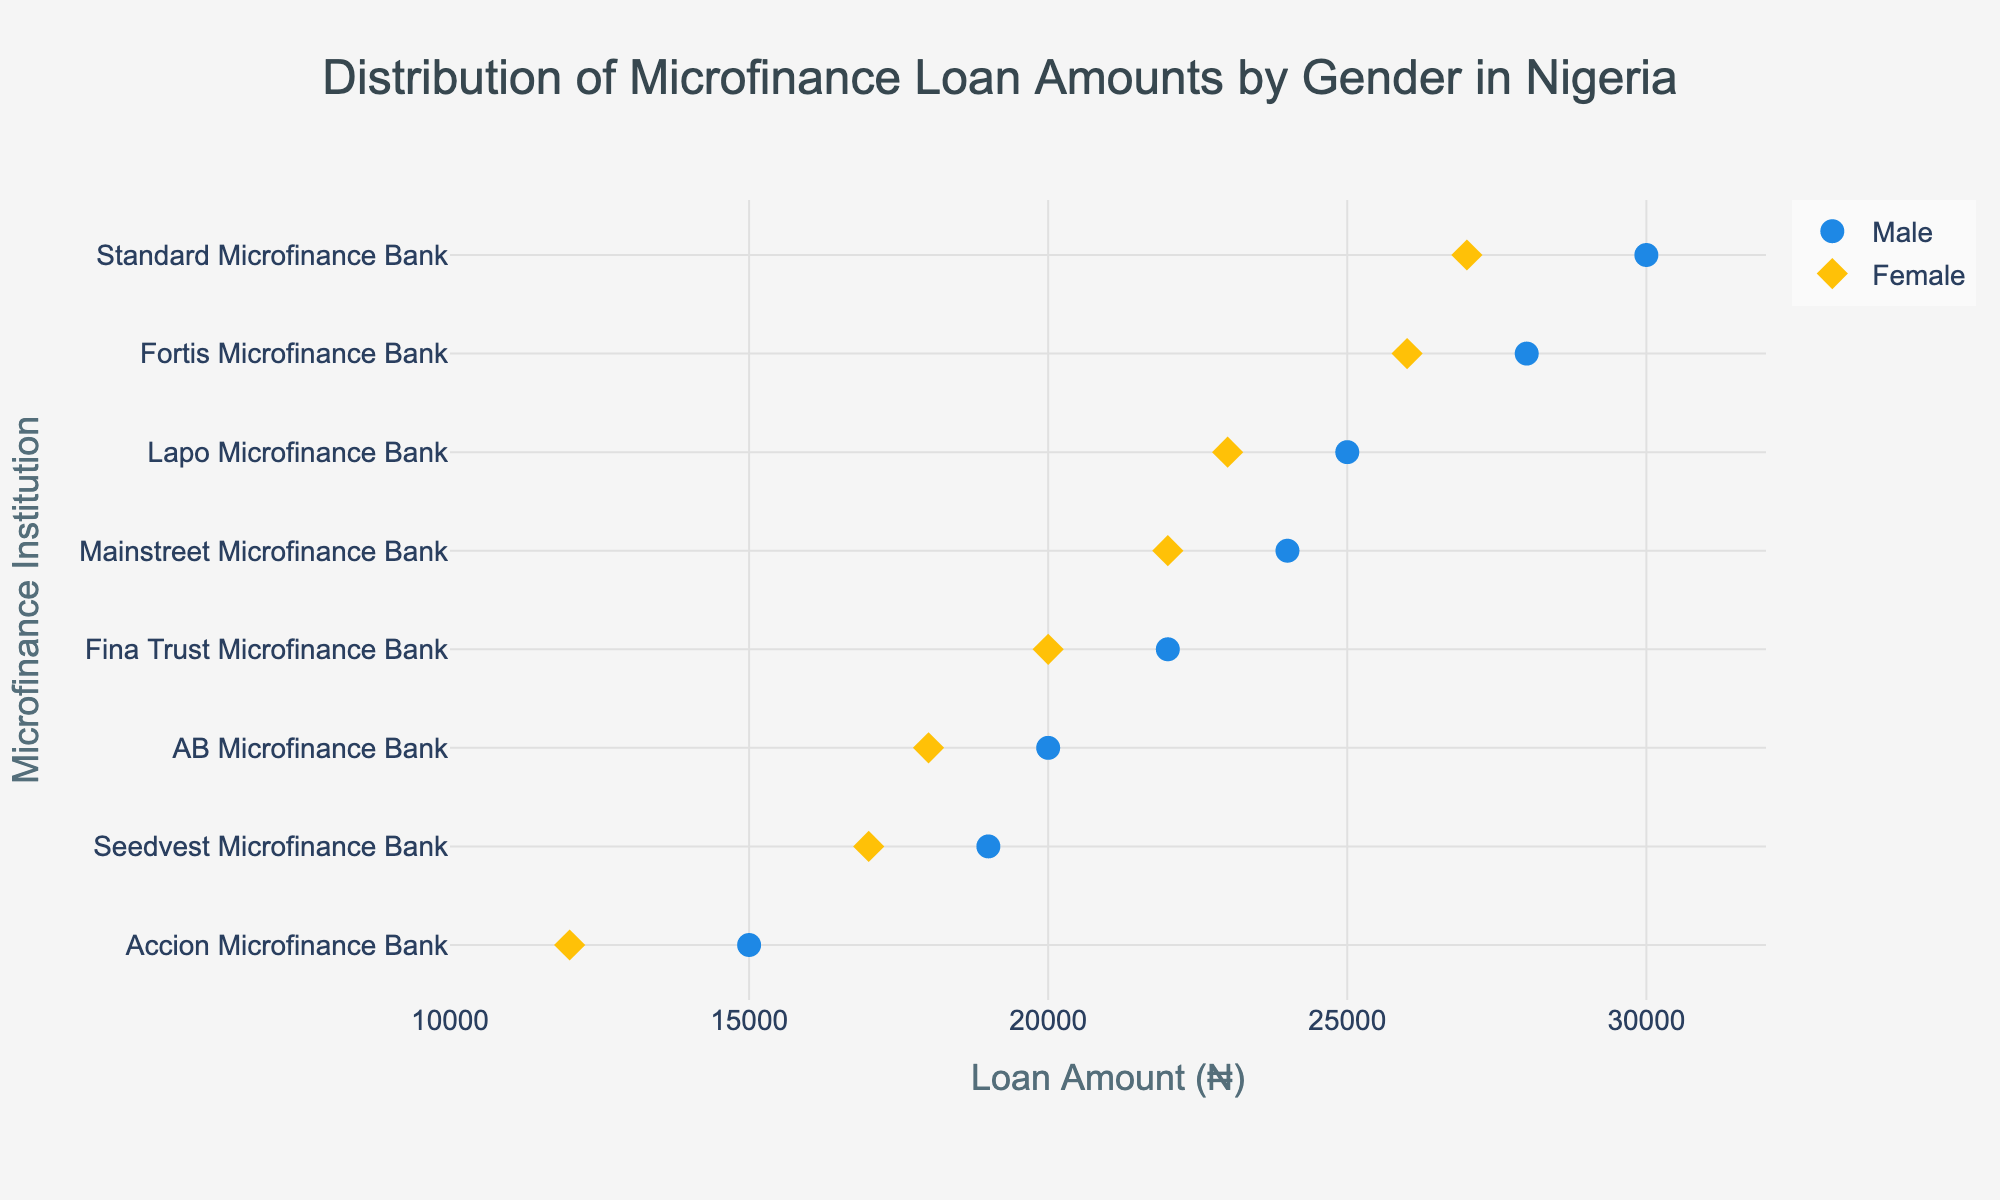what is the range of loan amounts for Standard Microfinance Bank? The male loan amount for Standard Microfinance Bank is ₦30,000 and the female loan amount is ₦27,000. The range is calculated as the difference between these values: 30,000 - 27,000.
Answer: ₦3,000 what is the average loan amount for AB Microfinance Bank? The loan amounts for AB Microfinance Bank are ₦20,000 for males and ₦18,000 for females. To find the average, sum these amounts and divide by 2: (20,000 + 18,000) / 2.
Answer: ₦19,000 How does the loan amount for males compare to females at Fina Trust Microfinance Bank? For Fina Trust Microfinance Bank, the loan amount for males is ₦22,000, while for females it is ₦20,000. Compare these two values: 22,000 is greater than 20,000.
Answer: Males receive ₦2,000 more Which microfinance institution offers the highest loan amount for females? To find this, compare the loan amounts for females across all institutions. Standard Microfinance Bank offers the highest at ₦27,000.
Answer: Standard Microfinance Bank What is the median loan amount for males across all microfinance institutions? The male loan amounts are: ₦15,000, ₦19,000, ₦20,000, ₦22,000, ₦24,000, ₦25,000, ₦28,000, and ₦30,000. Arrange these values in ascending order and find the middle value(s). For eight values, the median is the average of the 4th and 5th values: (22,000 + 24,000) / 2.
Answer: ₦23,000 What is the difference in loan amounts between males and females at Lapo Microfinance Bank? For Lapo Microfinance Bank, the loan amount for males is ₦25,000, and for females, it is ₦23,000. Find the difference: 25,000 - 23,000.
Answer: ₦2,000 Which microfinance institution has the smallest loan amount difference between genders? Compare the differences in loan amounts between males and females for each institution. Accion Microfinance Bank has the smallest difference: ₦15,000 (male) - ₦12,000 (female) = ₦3,000.
Answer: Accion Microfinance Bank What percentage of the institutions provide a higher loan amount to males than females? Count the number of institutions where males receive higher loans than females: 8 institutions provide higher loans to males. There are 8 institutions in total. The percentage is (8/8) * 100.
Answer: 100% What is the total combined loan amount for both genders at Fortis Microfinance Bank? The loan amounts at Fortis Microfinance Bank are ₦28,000 for males and ₦26,000 for females. Sum these amounts to find the total: 28,000 + 26,000.
Answer: ₦54,000 